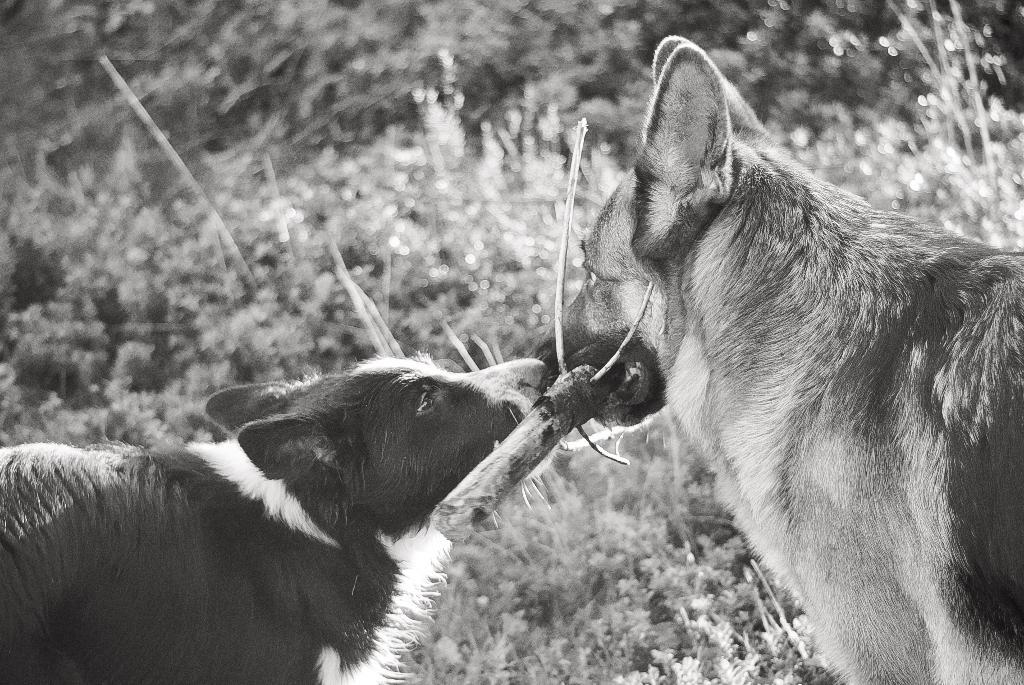What is the dog on the right side of the image doing? The dog on the right side of the image is holding a stick with its mouth. Is there another dog in the image? Yes, there is another dog beside the first dog. What can be seen in the background of the image? There are plants and trees visible in the background. What type of loaf can be seen in the image? There is no loaf present in the image. Can you tell me how many pies are being baked by the farm in the image? There is no farm or pies present in the image. 